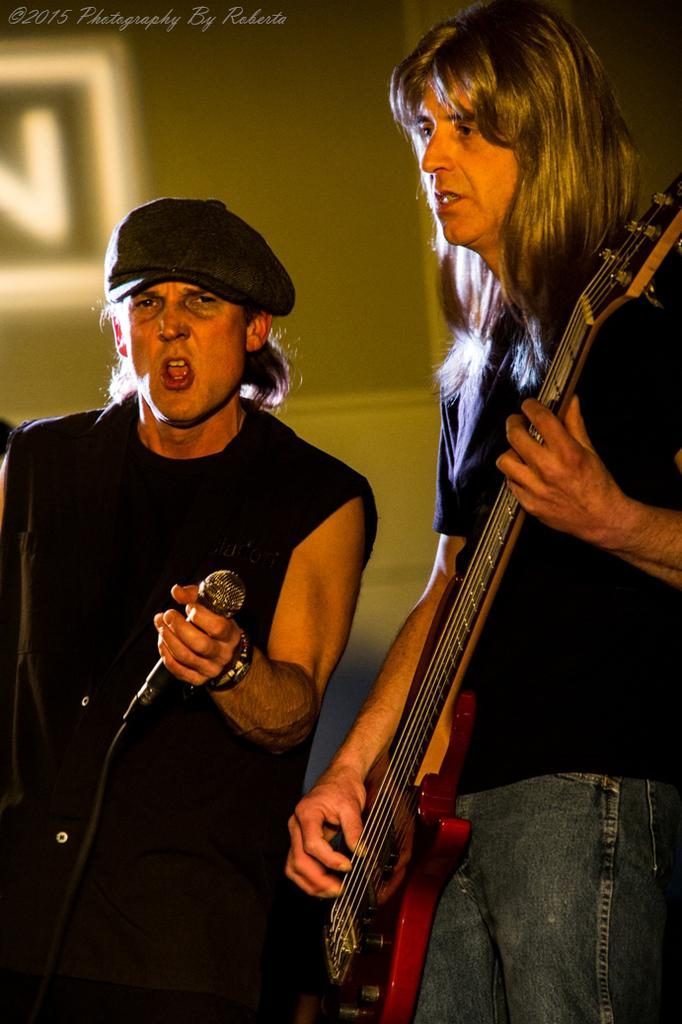How many people are in the image? There are two persons in the image. What are the two people holding? One person is holding a guitar, and the other person is holding a microphone. What is the person with the microphone doing? The person with the microphone is singing. How does the person with the microphone express their approval for the guitar player's performance? There is no indication in the image that the person with the microphone is expressing approval or disapproval for the guitar player's performance. 